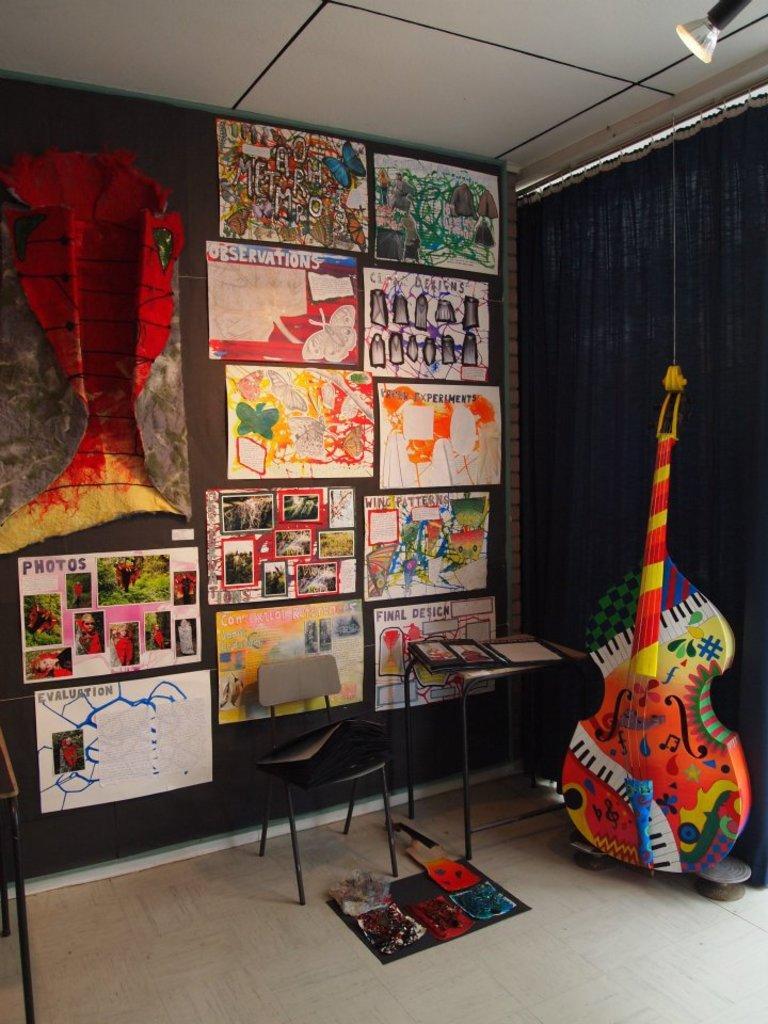Can you describe this image briefly? This picture is clicked inside the room. In the foreground we can see there are some objects placed on the top of the table and a chair and we can see a guitar and some objects are placed on the ground. In the background we can see the curtain, roof, posters attached to the wall and we can see the drawings, text and some pictures on the posters and we can see some other objects. 